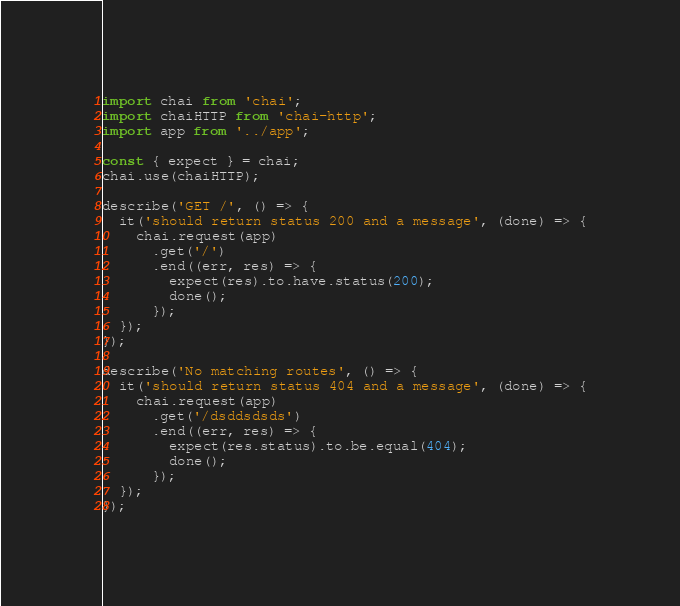<code> <loc_0><loc_0><loc_500><loc_500><_JavaScript_>import chai from 'chai';
import chaiHTTP from 'chai-http';
import app from '../app';

const { expect } = chai;
chai.use(chaiHTTP);

describe('GET /', () => {
  it('should return status 200 and a message', (done) => {
    chai.request(app)
      .get('/')
      .end((err, res) => {
        expect(res).to.have.status(200);
        done();
      });
  });
});

describe('No matching routes', () => {
  it('should return status 404 and a message', (done) => {
    chai.request(app)
      .get('/dsddsdsds')
      .end((err, res) => {
        expect(res.status).to.be.equal(404);
        done();
      });
  });
});
</code> 